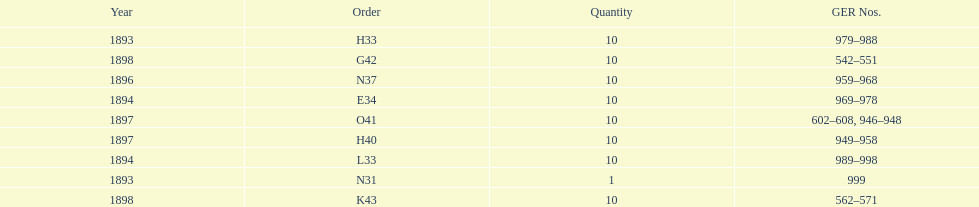Was the number higher in 1894 or 1893? 1894. 